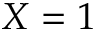<formula> <loc_0><loc_0><loc_500><loc_500>X = 1</formula> 